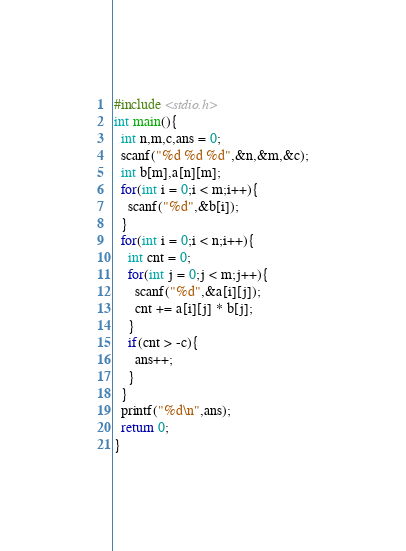<code> <loc_0><loc_0><loc_500><loc_500><_C_>#include <stdio.h>
int main(){
  int n,m,c,ans = 0;
  scanf("%d %d %d",&n,&m,&c);
  int b[m],a[n][m];
  for(int i = 0;i < m;i++){
    scanf("%d",&b[i]);
  }
  for(int i = 0;i < n;i++){
    int cnt = 0;
    for(int j = 0;j < m;j++){
      scanf("%d",&a[i][j]);
      cnt += a[i][j] * b[j];
    }
    if(cnt > -c){
      ans++;
    }
  }
  printf("%d\n",ans);
  return 0;
}</code> 